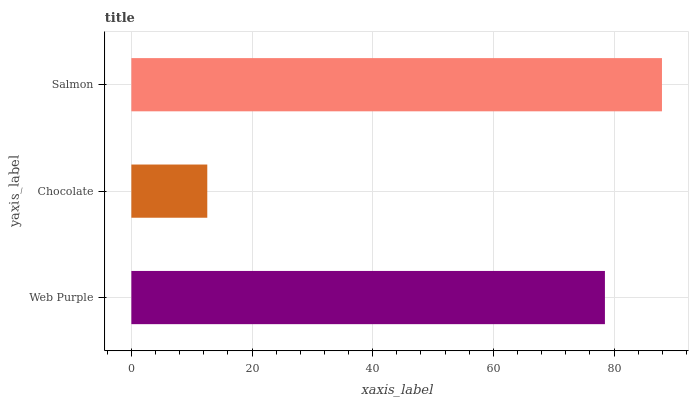Is Chocolate the minimum?
Answer yes or no. Yes. Is Salmon the maximum?
Answer yes or no. Yes. Is Salmon the minimum?
Answer yes or no. No. Is Chocolate the maximum?
Answer yes or no. No. Is Salmon greater than Chocolate?
Answer yes or no. Yes. Is Chocolate less than Salmon?
Answer yes or no. Yes. Is Chocolate greater than Salmon?
Answer yes or no. No. Is Salmon less than Chocolate?
Answer yes or no. No. Is Web Purple the high median?
Answer yes or no. Yes. Is Web Purple the low median?
Answer yes or no. Yes. Is Salmon the high median?
Answer yes or no. No. Is Chocolate the low median?
Answer yes or no. No. 